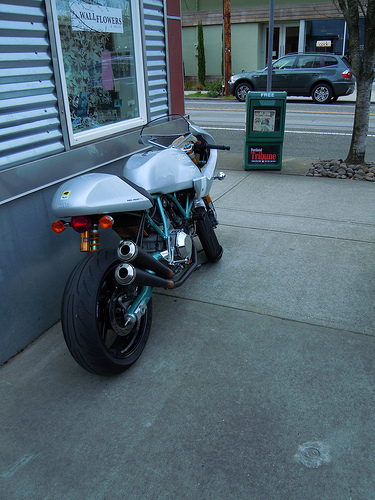<image>
Is the car behind the bike? No. The car is not behind the bike. From this viewpoint, the car appears to be positioned elsewhere in the scene. Is there a bin in front of the bike? Yes. The bin is positioned in front of the bike, appearing closer to the camera viewpoint. Where is the newspaper machine in relation to the road? Is it in front of the road? Yes. The newspaper machine is positioned in front of the road, appearing closer to the camera viewpoint. 